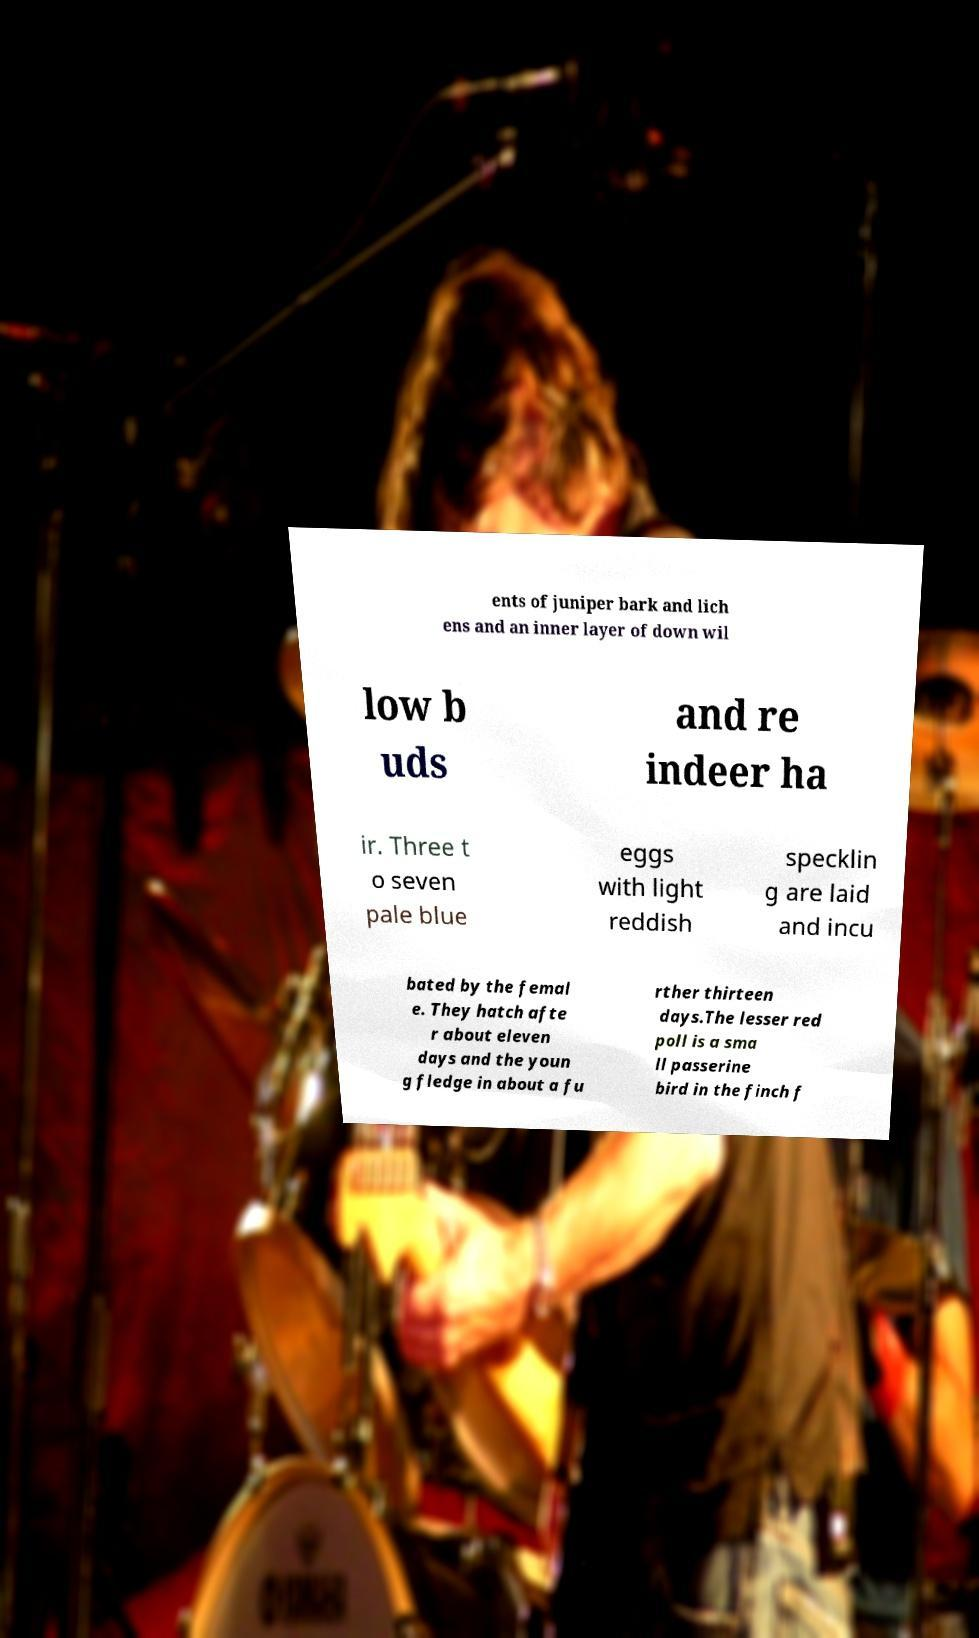Can you read and provide the text displayed in the image?This photo seems to have some interesting text. Can you extract and type it out for me? ents of juniper bark and lich ens and an inner layer of down wil low b uds and re indeer ha ir. Three t o seven pale blue eggs with light reddish specklin g are laid and incu bated by the femal e. They hatch afte r about eleven days and the youn g fledge in about a fu rther thirteen days.The lesser red poll is a sma ll passerine bird in the finch f 